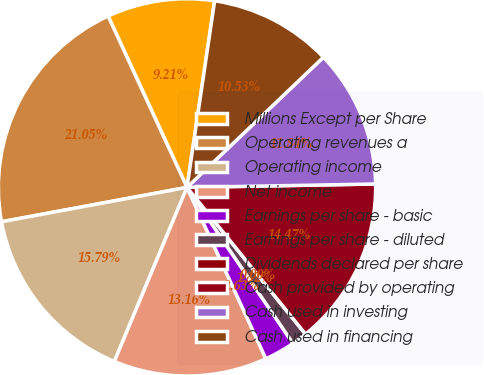<chart> <loc_0><loc_0><loc_500><loc_500><pie_chart><fcel>Millions Except per Share<fcel>Operating revenues a<fcel>Operating income<fcel>Net income<fcel>Earnings per share - basic<fcel>Earnings per share - diluted<fcel>Dividends declared per share<fcel>Cash provided by operating<fcel>Cash used in investing<fcel>Cash used in financing<nl><fcel>9.21%<fcel>21.05%<fcel>15.79%<fcel>13.16%<fcel>2.63%<fcel>1.32%<fcel>0.0%<fcel>14.47%<fcel>11.84%<fcel>10.53%<nl></chart> 